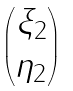<formula> <loc_0><loc_0><loc_500><loc_500>\begin{pmatrix} \xi _ { 2 } \\ \eta _ { 2 } \end{pmatrix}</formula> 